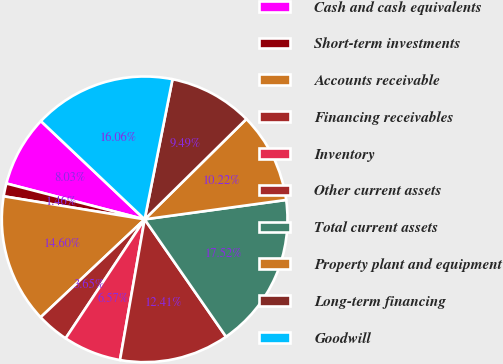Convert chart to OTSL. <chart><loc_0><loc_0><loc_500><loc_500><pie_chart><fcel>Cash and cash equivalents<fcel>Short-term investments<fcel>Accounts receivable<fcel>Financing receivables<fcel>Inventory<fcel>Other current assets<fcel>Total current assets<fcel>Property plant and equipment<fcel>Long-term financing<fcel>Goodwill<nl><fcel>8.03%<fcel>1.46%<fcel>14.6%<fcel>3.65%<fcel>6.57%<fcel>12.41%<fcel>17.52%<fcel>10.22%<fcel>9.49%<fcel>16.06%<nl></chart> 